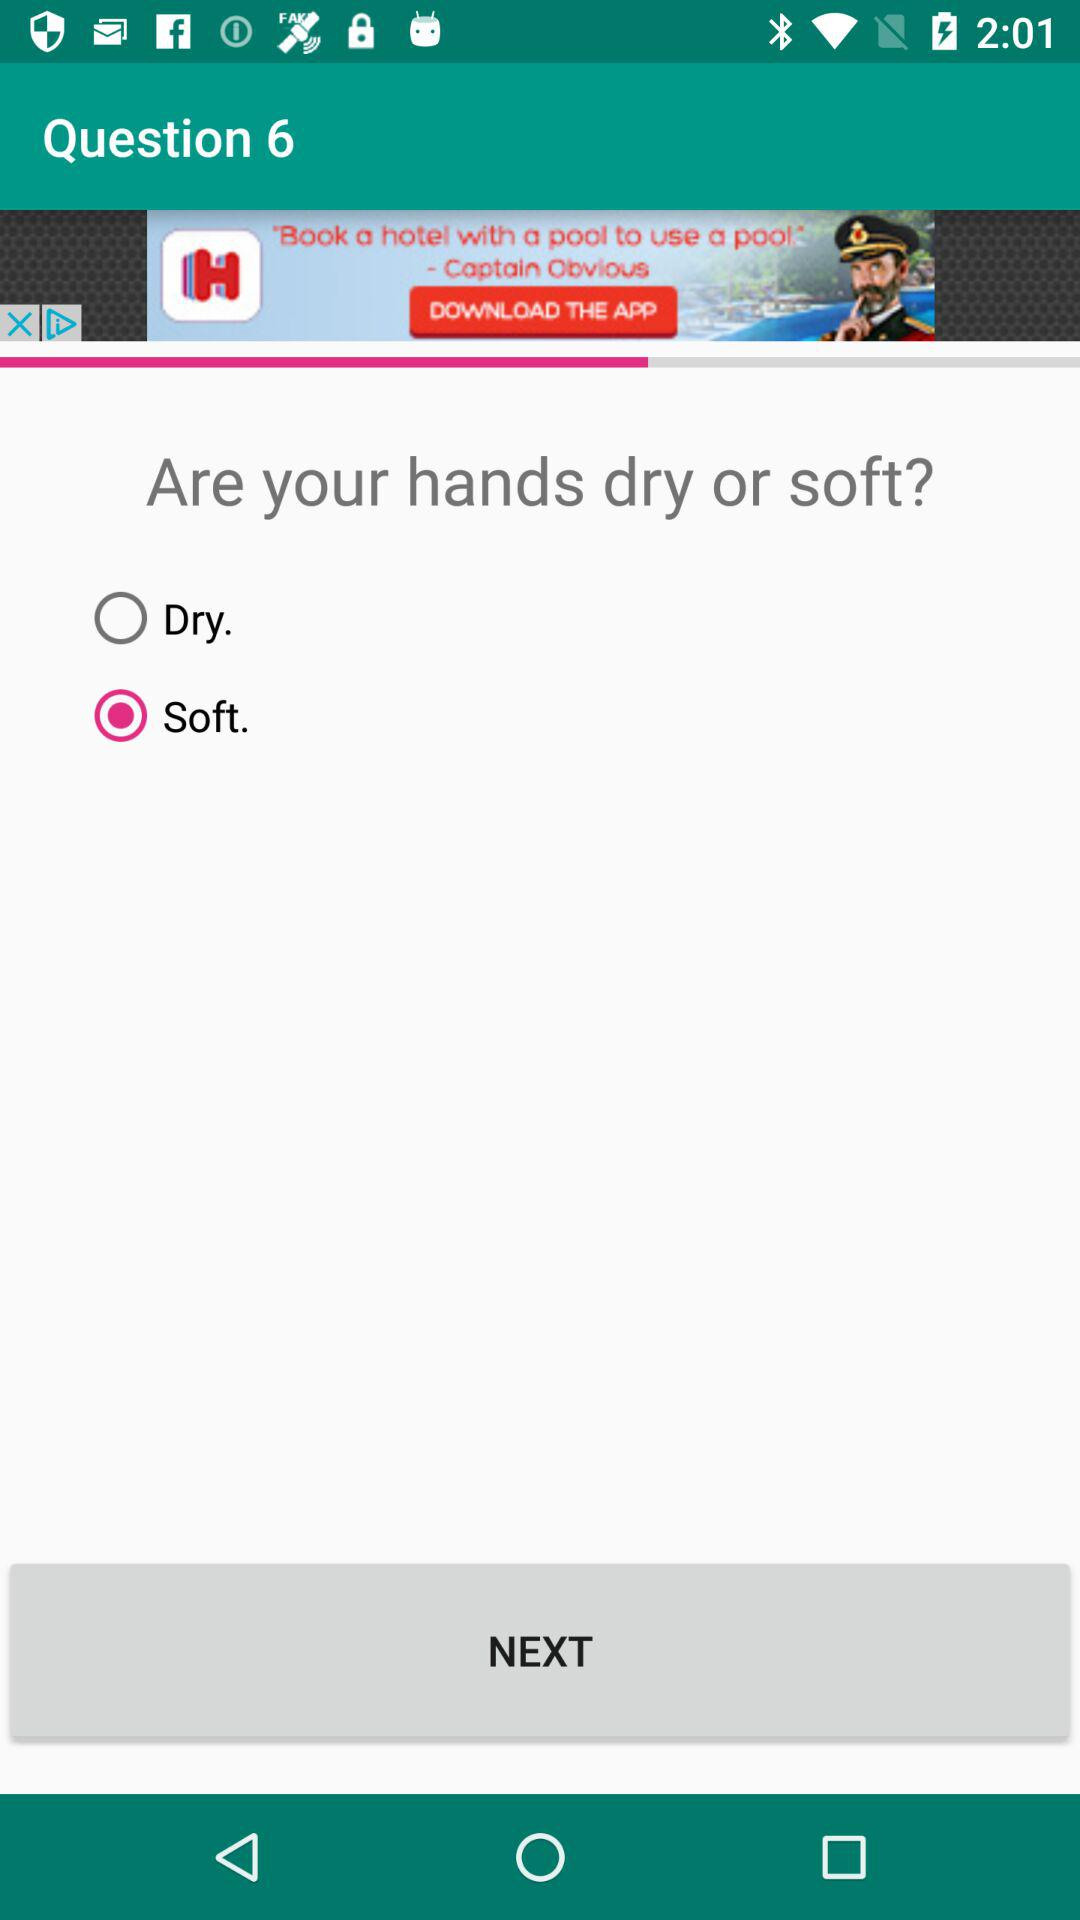At which question am I? You are at the sixth question. 